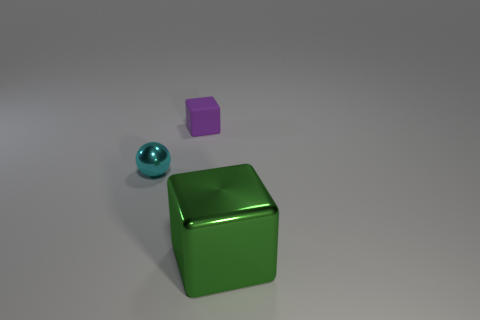Add 1 big metallic cubes. How many objects exist? 4 Subtract all cubes. How many objects are left? 1 Add 2 purple matte blocks. How many purple matte blocks exist? 3 Subtract 0 blue cylinders. How many objects are left? 3 Subtract all small cyan things. Subtract all purple rubber objects. How many objects are left? 1 Add 2 cyan objects. How many cyan objects are left? 3 